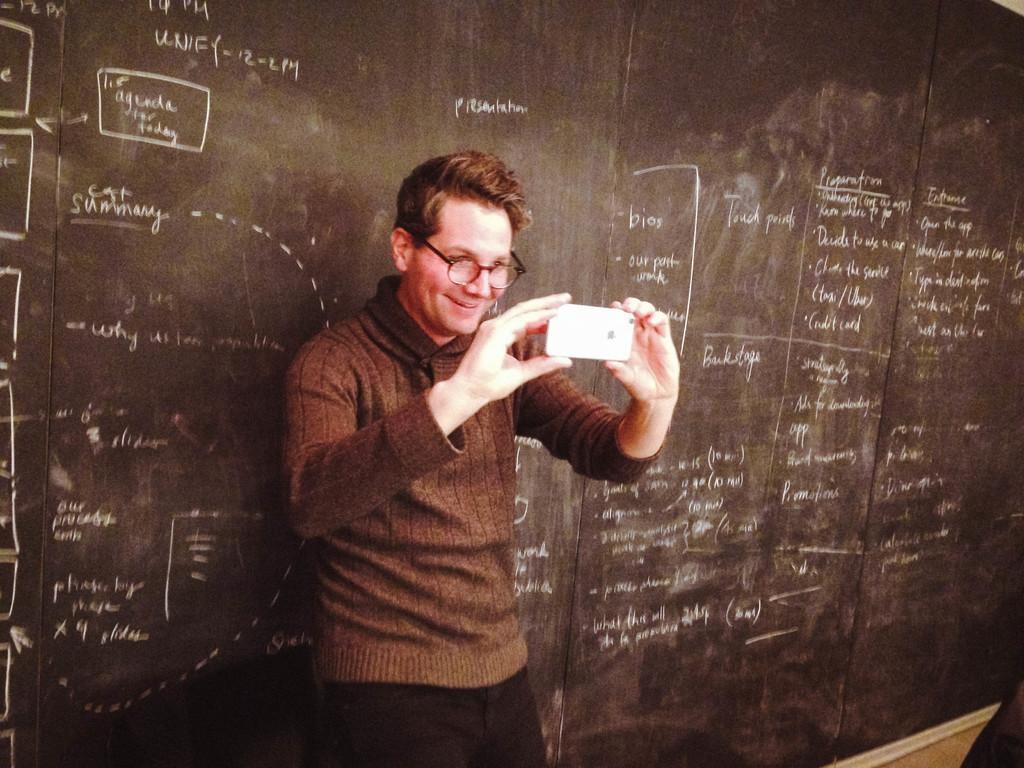Please provide a concise description of this image. In this image, we can see a person in front of the board holding a phone with his hands. This person is wearing clothes and spectacles. 